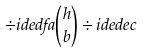<formula> <loc_0><loc_0><loc_500><loc_500>\div i d e d { f } { a } \binom { h } { b } \div i d e d { e } { c }</formula> 